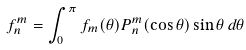<formula> <loc_0><loc_0><loc_500><loc_500>f _ { n } ^ { m } = \int _ { 0 } ^ { \pi } f _ { m } ( \theta ) P _ { n } ^ { m } ( \cos \theta ) \sin \theta \, d \theta</formula> 